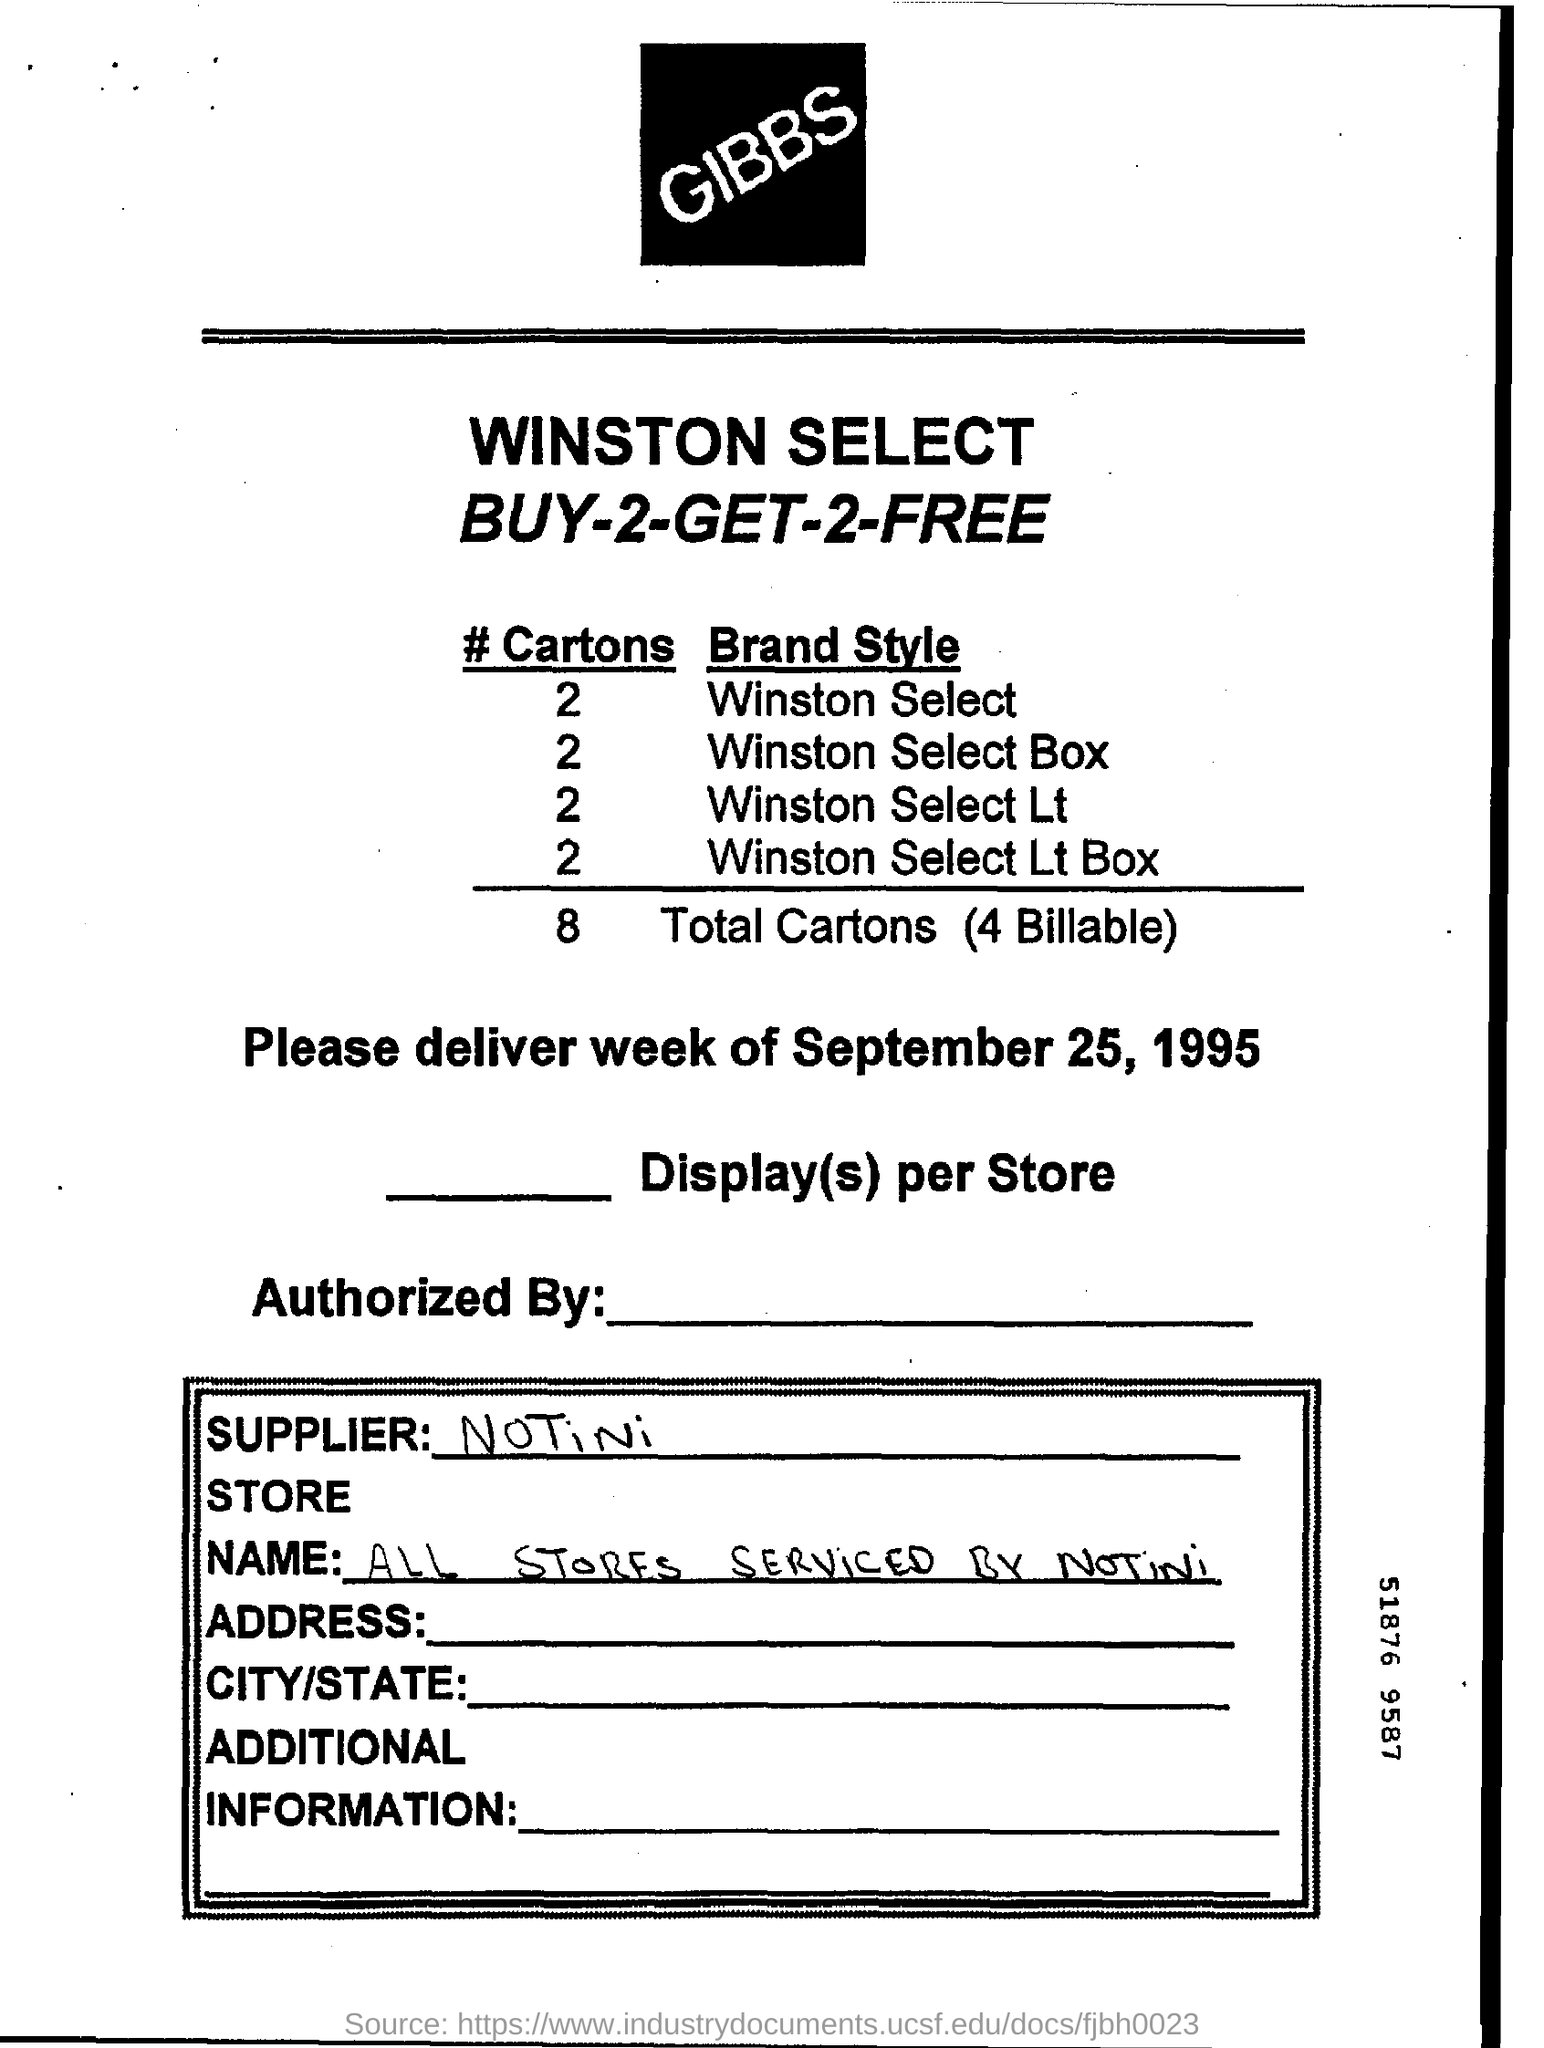Outline some significant characteristics in this image. It is mentioned that two cartons of Winston Select are present. The total number of cartons mentioned is 8. The number of cartons mentioned for Winston Select boxes is 2. The supplier mentioned is notini. The date mentioned is September 25, 1995. 